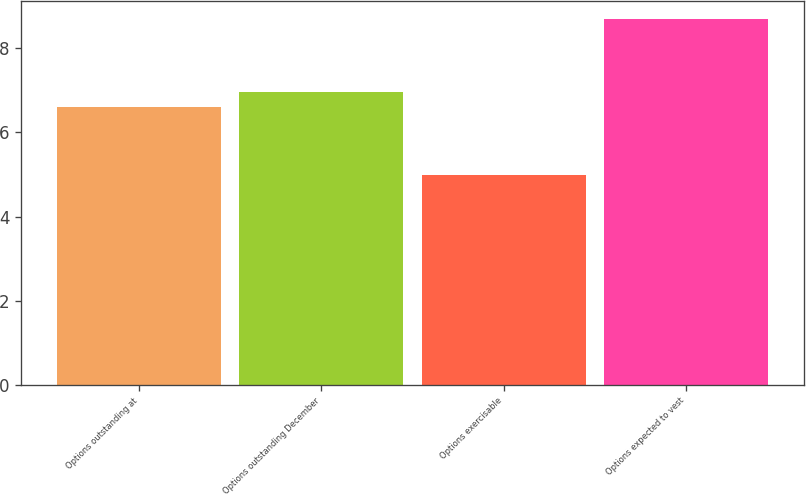<chart> <loc_0><loc_0><loc_500><loc_500><bar_chart><fcel>Options outstanding at<fcel>Options outstanding December<fcel>Options exercisable<fcel>Options expected to vest<nl><fcel>6.6<fcel>6.97<fcel>5<fcel>8.7<nl></chart> 